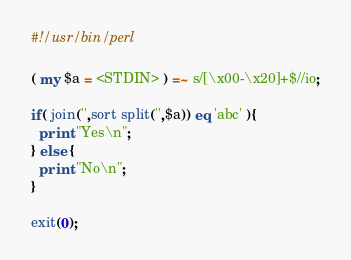<code> <loc_0><loc_0><loc_500><loc_500><_Perl_>#!/usr/bin/perl

( my $a = <STDIN> ) =~ s/[\x00-\x20]+$//io;

if( join('',sort split('',$a)) eq 'abc' ){
  print "Yes\n";
} else {
  print "No\n";
}

exit(0);
</code> 